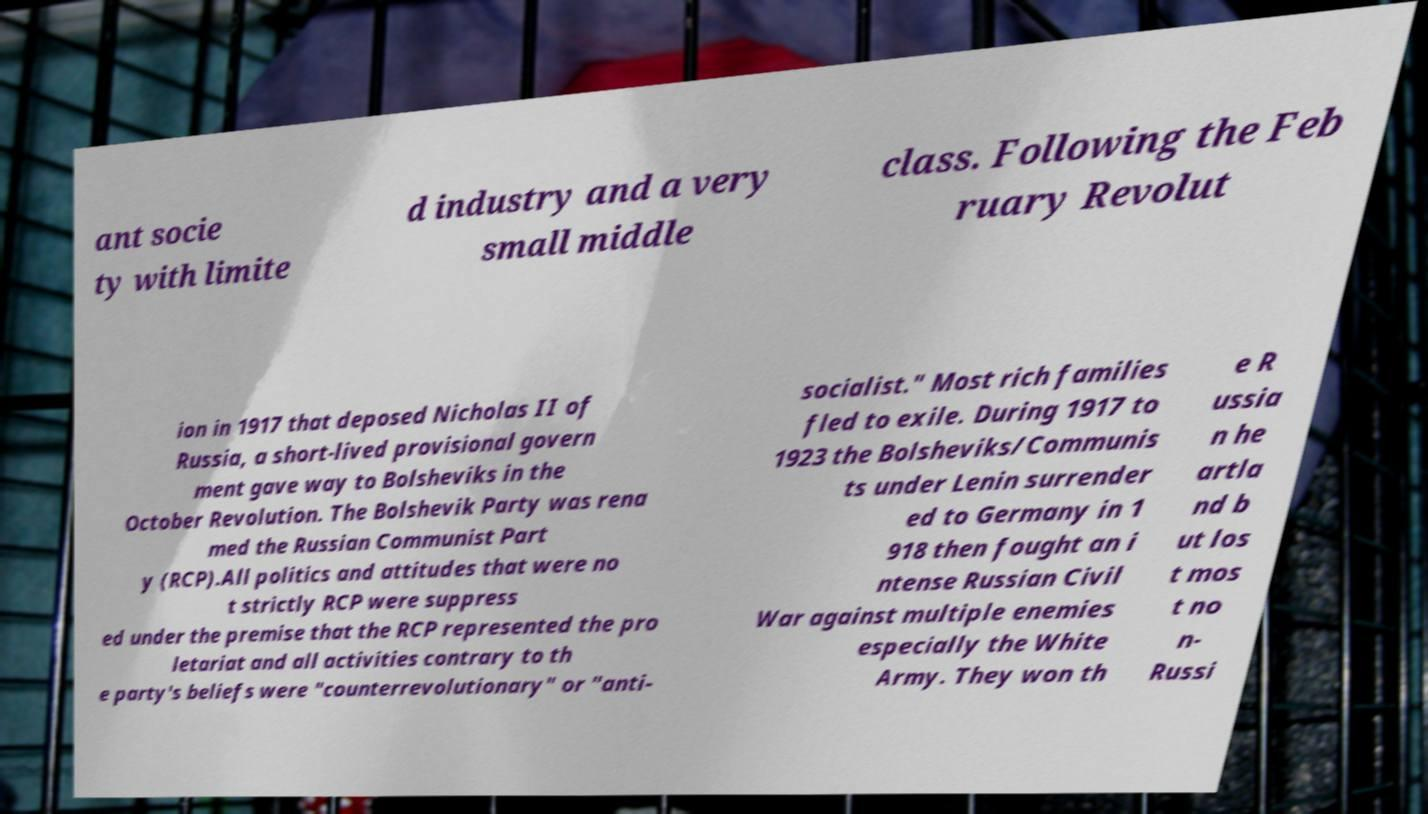Could you assist in decoding the text presented in this image and type it out clearly? ant socie ty with limite d industry and a very small middle class. Following the Feb ruary Revolut ion in 1917 that deposed Nicholas II of Russia, a short-lived provisional govern ment gave way to Bolsheviks in the October Revolution. The Bolshevik Party was rena med the Russian Communist Part y (RCP).All politics and attitudes that were no t strictly RCP were suppress ed under the premise that the RCP represented the pro letariat and all activities contrary to th e party's beliefs were "counterrevolutionary" or "anti- socialist." Most rich families fled to exile. During 1917 to 1923 the Bolsheviks/Communis ts under Lenin surrender ed to Germany in 1 918 then fought an i ntense Russian Civil War against multiple enemies especially the White Army. They won th e R ussia n he artla nd b ut los t mos t no n- Russi 